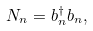<formula> <loc_0><loc_0><loc_500><loc_500>N _ { n } = b ^ { \dagger } _ { n } b _ { n } ,</formula> 